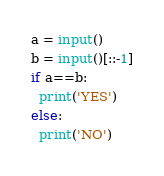Convert code to text. <code><loc_0><loc_0><loc_500><loc_500><_Python_>a = input()
b = input()[::-1]
if a==b:
  print('YES')
else:
  print('NO')</code> 